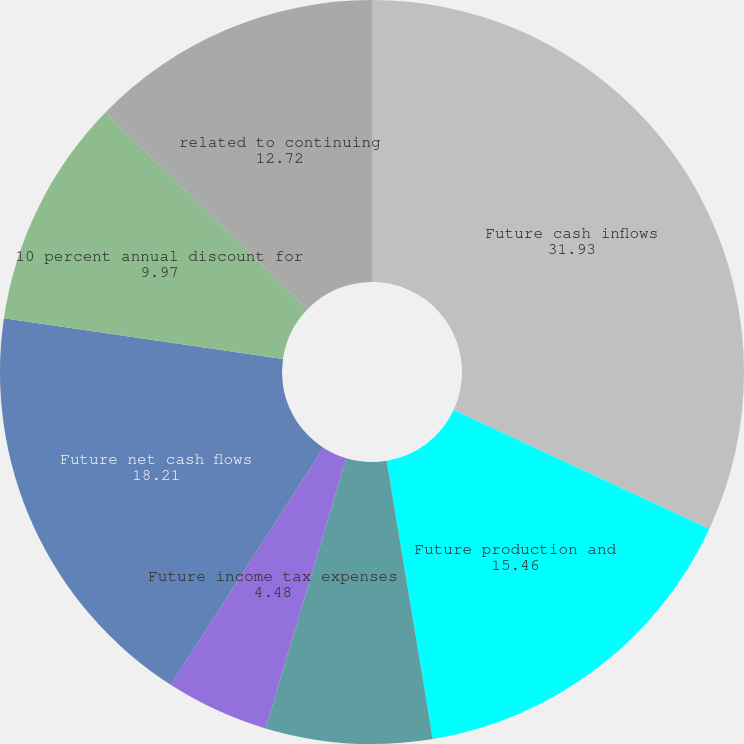<chart> <loc_0><loc_0><loc_500><loc_500><pie_chart><fcel>Future cash inflows<fcel>Future production and<fcel>Future development costs<fcel>Future income tax expenses<fcel>Future net cash flows<fcel>10 percent annual discount for<fcel>related to continuing<nl><fcel>31.93%<fcel>15.46%<fcel>7.23%<fcel>4.48%<fcel>18.21%<fcel>9.97%<fcel>12.72%<nl></chart> 